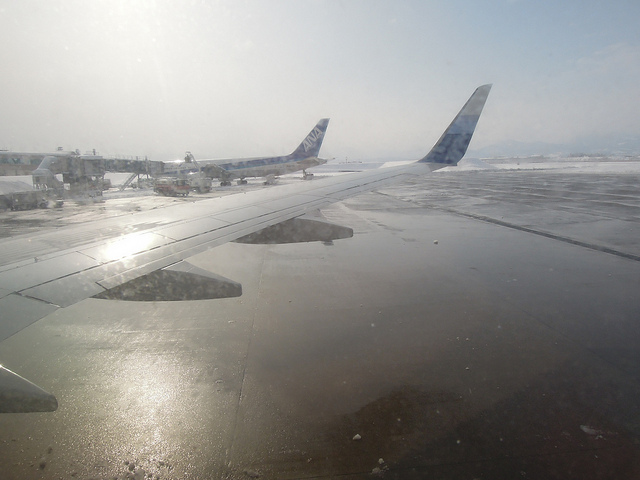Identify the text contained in this image. ANA 